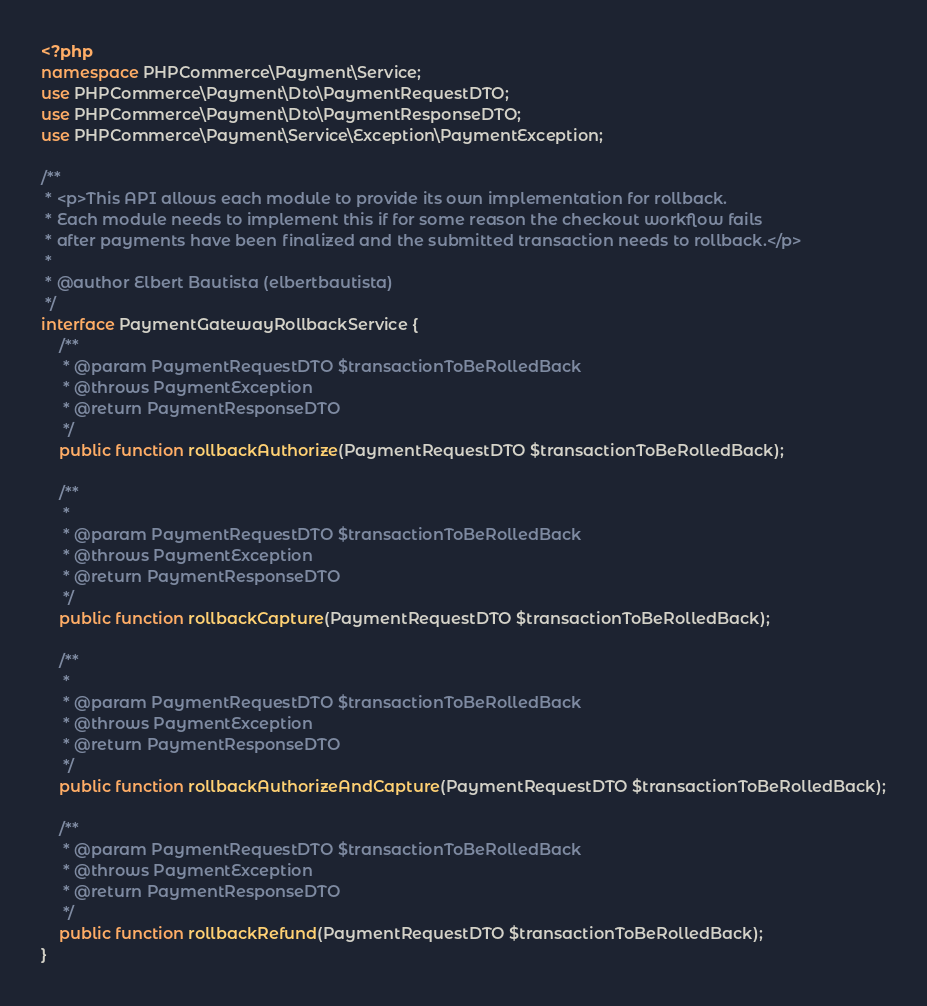Convert code to text. <code><loc_0><loc_0><loc_500><loc_500><_PHP_><?php
namespace PHPCommerce\Payment\Service;
use PHPCommerce\Payment\Dto\PaymentRequestDTO;
use PHPCommerce\Payment\Dto\PaymentResponseDTO;
use PHPCommerce\Payment\Service\Exception\PaymentException;

/**
 * <p>This API allows each module to provide its own implementation for rollback.
 * Each module needs to implement this if for some reason the checkout workflow fails
 * after payments have been finalized and the submitted transaction needs to rollback.</p>
 *
 * @author Elbert Bautista (elbertbautista)
 */
interface PaymentGatewayRollbackService {
    /**
     * @param PaymentRequestDTO $transactionToBeRolledBack
     * @throws PaymentException
     * @return PaymentResponseDTO
     */
    public function rollbackAuthorize(PaymentRequestDTO $transactionToBeRolledBack);

    /**
     *
     * @param PaymentRequestDTO $transactionToBeRolledBack
     * @throws PaymentException
     * @return PaymentResponseDTO
     */
    public function rollbackCapture(PaymentRequestDTO $transactionToBeRolledBack);

    /**
     *
     * @param PaymentRequestDTO $transactionToBeRolledBack
     * @throws PaymentException
     * @return PaymentResponseDTO
     */
    public function rollbackAuthorizeAndCapture(PaymentRequestDTO $transactionToBeRolledBack);

    /**
     * @param PaymentRequestDTO $transactionToBeRolledBack
     * @throws PaymentException
     * @return PaymentResponseDTO
     */
    public function rollbackRefund(PaymentRequestDTO $transactionToBeRolledBack);
}
</code> 